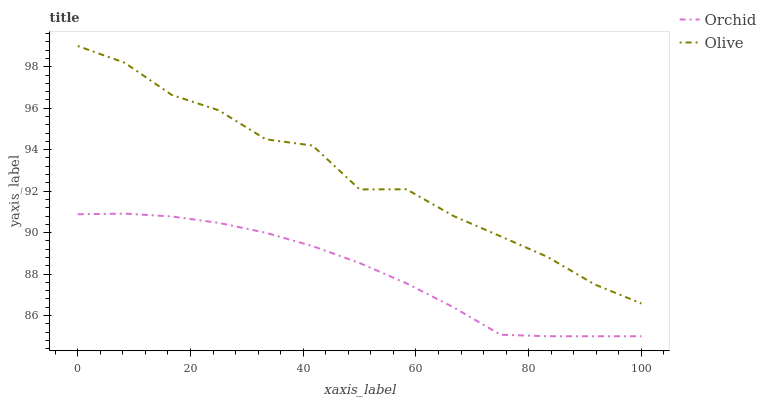Does Orchid have the minimum area under the curve?
Answer yes or no. Yes. Does Olive have the maximum area under the curve?
Answer yes or no. Yes. Does Orchid have the maximum area under the curve?
Answer yes or no. No. Is Orchid the smoothest?
Answer yes or no. Yes. Is Olive the roughest?
Answer yes or no. Yes. Is Orchid the roughest?
Answer yes or no. No. Does Orchid have the highest value?
Answer yes or no. No. Is Orchid less than Olive?
Answer yes or no. Yes. Is Olive greater than Orchid?
Answer yes or no. Yes. Does Orchid intersect Olive?
Answer yes or no. No. 